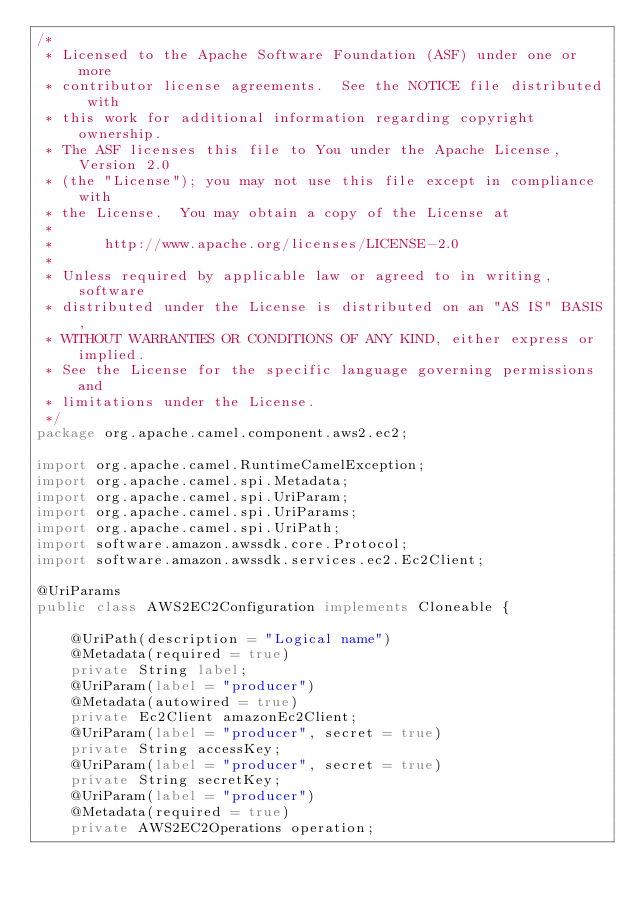<code> <loc_0><loc_0><loc_500><loc_500><_Java_>/*
 * Licensed to the Apache Software Foundation (ASF) under one or more
 * contributor license agreements.  See the NOTICE file distributed with
 * this work for additional information regarding copyright ownership.
 * The ASF licenses this file to You under the Apache License, Version 2.0
 * (the "License"); you may not use this file except in compliance with
 * the License.  You may obtain a copy of the License at
 *
 *      http://www.apache.org/licenses/LICENSE-2.0
 *
 * Unless required by applicable law or agreed to in writing, software
 * distributed under the License is distributed on an "AS IS" BASIS,
 * WITHOUT WARRANTIES OR CONDITIONS OF ANY KIND, either express or implied.
 * See the License for the specific language governing permissions and
 * limitations under the License.
 */
package org.apache.camel.component.aws2.ec2;

import org.apache.camel.RuntimeCamelException;
import org.apache.camel.spi.Metadata;
import org.apache.camel.spi.UriParam;
import org.apache.camel.spi.UriParams;
import org.apache.camel.spi.UriPath;
import software.amazon.awssdk.core.Protocol;
import software.amazon.awssdk.services.ec2.Ec2Client;

@UriParams
public class AWS2EC2Configuration implements Cloneable {

    @UriPath(description = "Logical name")
    @Metadata(required = true)
    private String label;
    @UriParam(label = "producer")
    @Metadata(autowired = true)
    private Ec2Client amazonEc2Client;
    @UriParam(label = "producer", secret = true)
    private String accessKey;
    @UriParam(label = "producer", secret = true)
    private String secretKey;
    @UriParam(label = "producer")
    @Metadata(required = true)
    private AWS2EC2Operations operation;</code> 